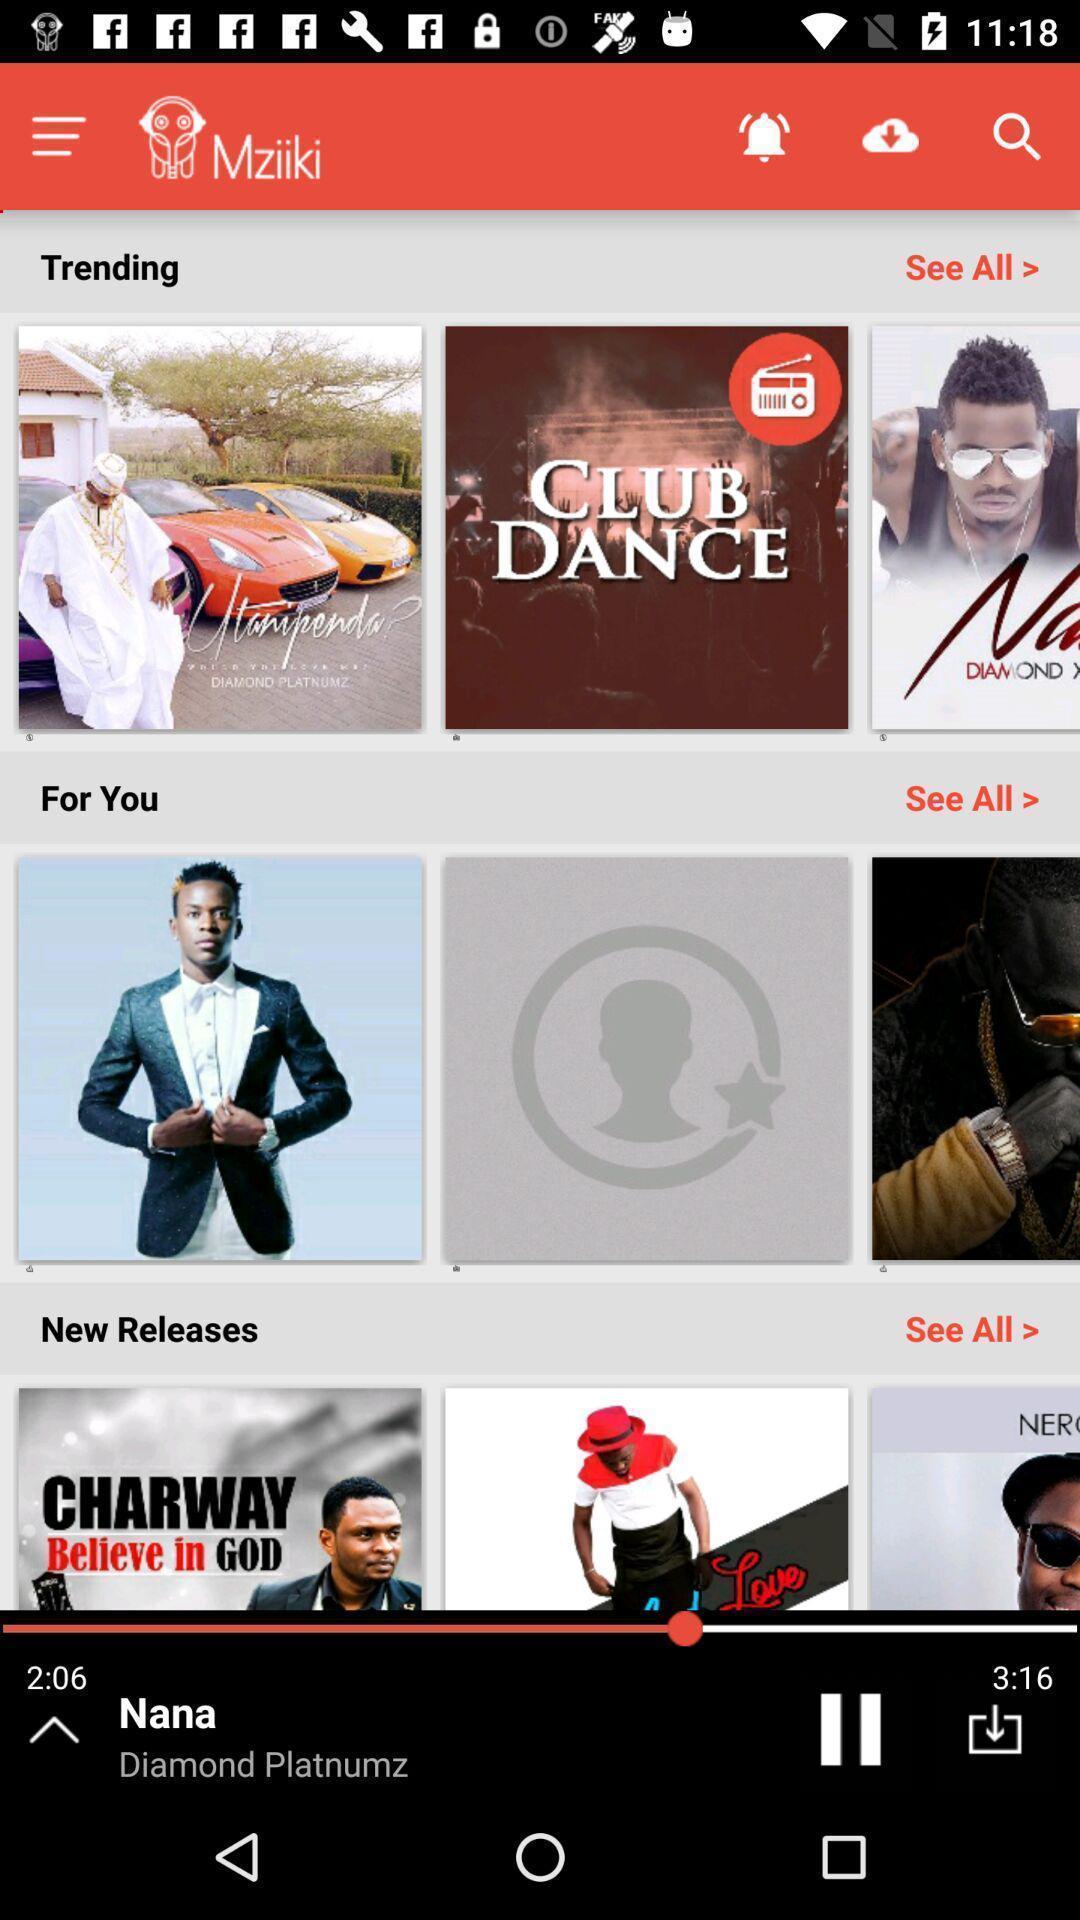Please provide a description for this image. Screen shows different music in music app. 